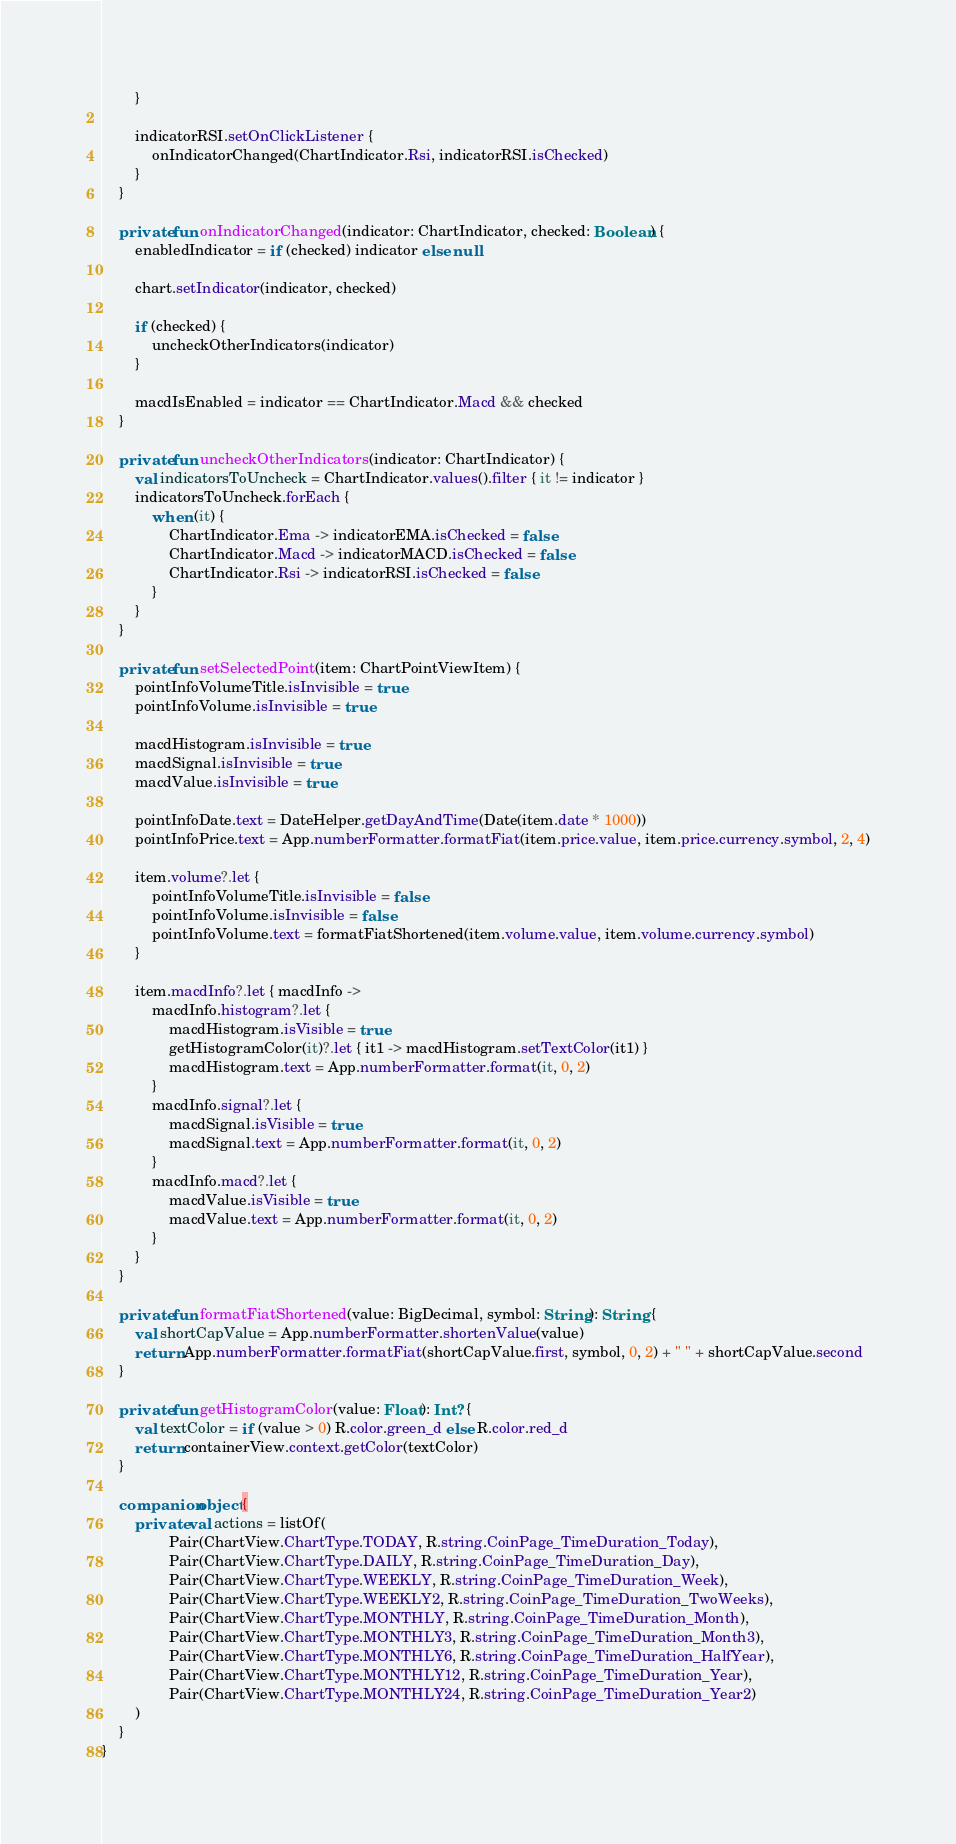Convert code to text. <code><loc_0><loc_0><loc_500><loc_500><_Kotlin_>        }

        indicatorRSI.setOnClickListener {
            onIndicatorChanged(ChartIndicator.Rsi, indicatorRSI.isChecked)
        }
    }

    private fun onIndicatorChanged(indicator: ChartIndicator, checked: Boolean) {
        enabledIndicator = if (checked) indicator else null

        chart.setIndicator(indicator, checked)

        if (checked) {
            uncheckOtherIndicators(indicator)
        }

        macdIsEnabled = indicator == ChartIndicator.Macd && checked
    }

    private fun uncheckOtherIndicators(indicator: ChartIndicator) {
        val indicatorsToUncheck = ChartIndicator.values().filter { it != indicator }
        indicatorsToUncheck.forEach {
            when (it) {
                ChartIndicator.Ema -> indicatorEMA.isChecked = false
                ChartIndicator.Macd -> indicatorMACD.isChecked = false
                ChartIndicator.Rsi -> indicatorRSI.isChecked = false
            }
        }
    }

    private fun setSelectedPoint(item: ChartPointViewItem) {
        pointInfoVolumeTitle.isInvisible = true
        pointInfoVolume.isInvisible = true

        macdHistogram.isInvisible = true
        macdSignal.isInvisible = true
        macdValue.isInvisible = true

        pointInfoDate.text = DateHelper.getDayAndTime(Date(item.date * 1000))
        pointInfoPrice.text = App.numberFormatter.formatFiat(item.price.value, item.price.currency.symbol, 2, 4)

        item.volume?.let {
            pointInfoVolumeTitle.isInvisible = false
            pointInfoVolume.isInvisible = false
            pointInfoVolume.text = formatFiatShortened(item.volume.value, item.volume.currency.symbol)
        }

        item.macdInfo?.let { macdInfo ->
            macdInfo.histogram?.let {
                macdHistogram.isVisible = true
                getHistogramColor(it)?.let { it1 -> macdHistogram.setTextColor(it1) }
                macdHistogram.text = App.numberFormatter.format(it, 0, 2)
            }
            macdInfo.signal?.let {
                macdSignal.isVisible = true
                macdSignal.text = App.numberFormatter.format(it, 0, 2)
            }
            macdInfo.macd?.let {
                macdValue.isVisible = true
                macdValue.text = App.numberFormatter.format(it, 0, 2)
            }
        }
    }

    private fun formatFiatShortened(value: BigDecimal, symbol: String): String {
        val shortCapValue = App.numberFormatter.shortenValue(value)
        return App.numberFormatter.formatFiat(shortCapValue.first, symbol, 0, 2) + " " + shortCapValue.second
    }

    private fun getHistogramColor(value: Float): Int? {
        val textColor = if (value > 0) R.color.green_d else R.color.red_d
        return containerView.context.getColor(textColor)
    }

    companion object {
        private val actions = listOf(
                Pair(ChartView.ChartType.TODAY, R.string.CoinPage_TimeDuration_Today),
                Pair(ChartView.ChartType.DAILY, R.string.CoinPage_TimeDuration_Day),
                Pair(ChartView.ChartType.WEEKLY, R.string.CoinPage_TimeDuration_Week),
                Pair(ChartView.ChartType.WEEKLY2, R.string.CoinPage_TimeDuration_TwoWeeks),
                Pair(ChartView.ChartType.MONTHLY, R.string.CoinPage_TimeDuration_Month),
                Pair(ChartView.ChartType.MONTHLY3, R.string.CoinPage_TimeDuration_Month3),
                Pair(ChartView.ChartType.MONTHLY6, R.string.CoinPage_TimeDuration_HalfYear),
                Pair(ChartView.ChartType.MONTHLY12, R.string.CoinPage_TimeDuration_Year),
                Pair(ChartView.ChartType.MONTHLY24, R.string.CoinPage_TimeDuration_Year2)
        )
    }
}
</code> 